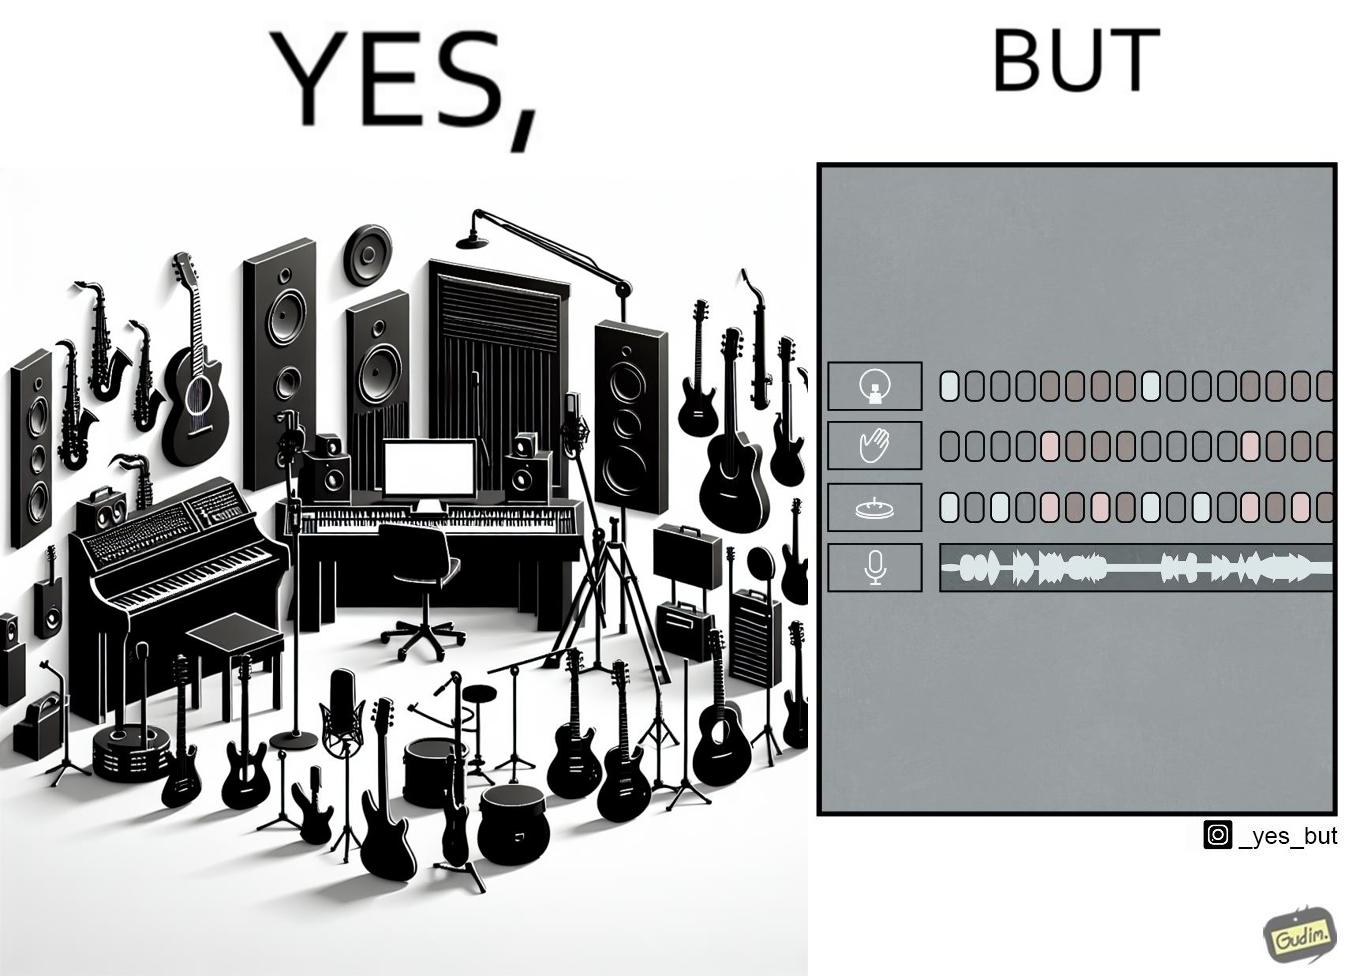What does this image depict? The image overall is funny because even though people have great music studios and instruments to create and record music, they use electronic replacements of the musical instruments to achieve the task. 